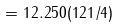<formula> <loc_0><loc_0><loc_500><loc_500>= 1 2 . 2 5 0 ( 1 2 1 / 4 )</formula> 